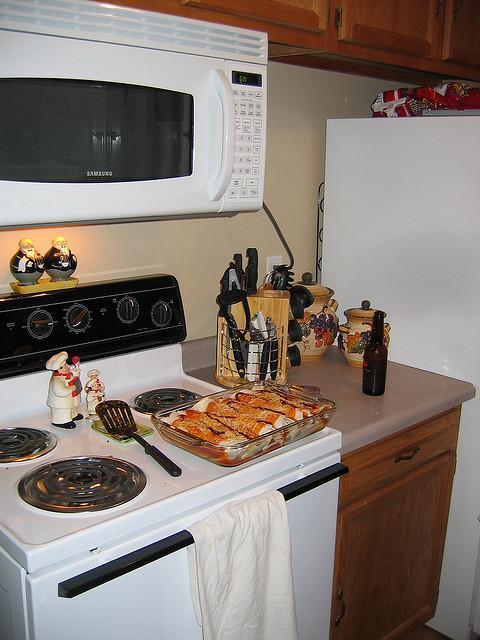How many burners does the stove have?
Give a very brief answer. 4. How many ovens are there?
Give a very brief answer. 1. 